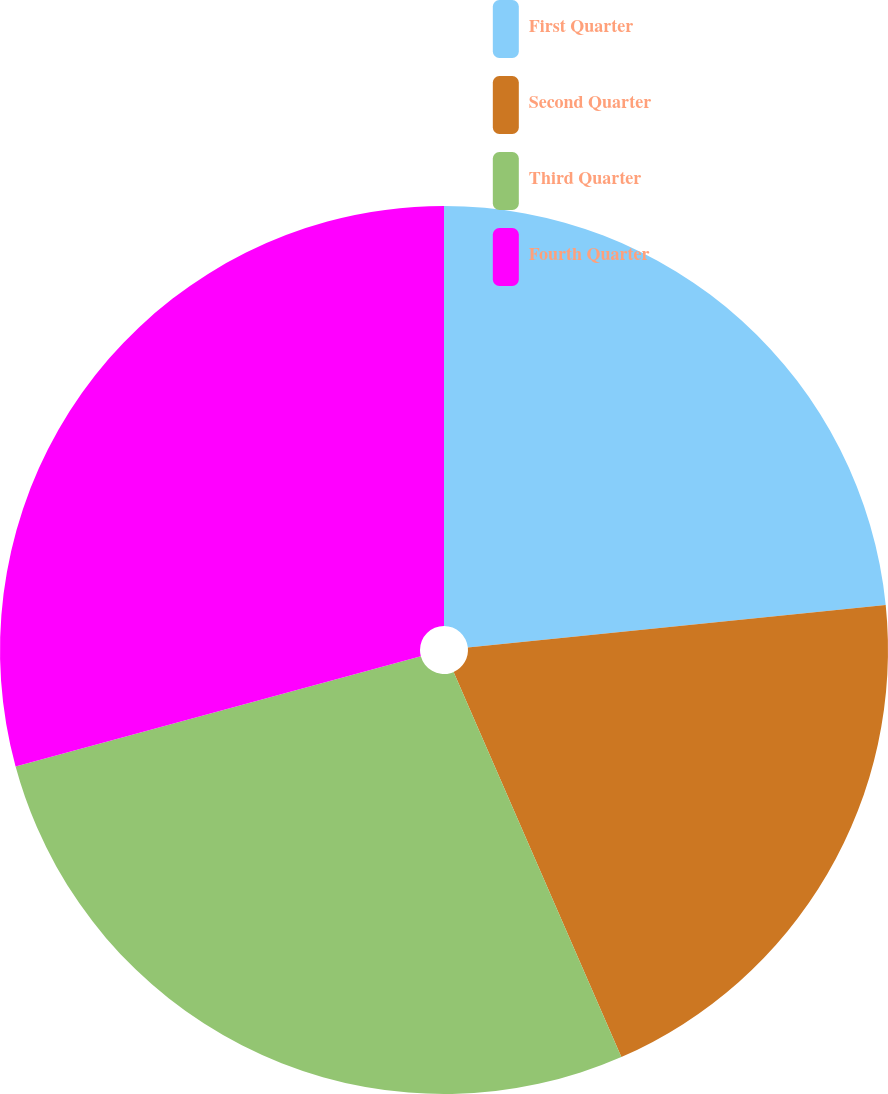Convert chart. <chart><loc_0><loc_0><loc_500><loc_500><pie_chart><fcel>First Quarter<fcel>Second Quarter<fcel>Third Quarter<fcel>Fourth Quarter<nl><fcel>23.38%<fcel>20.08%<fcel>27.31%<fcel>29.23%<nl></chart> 